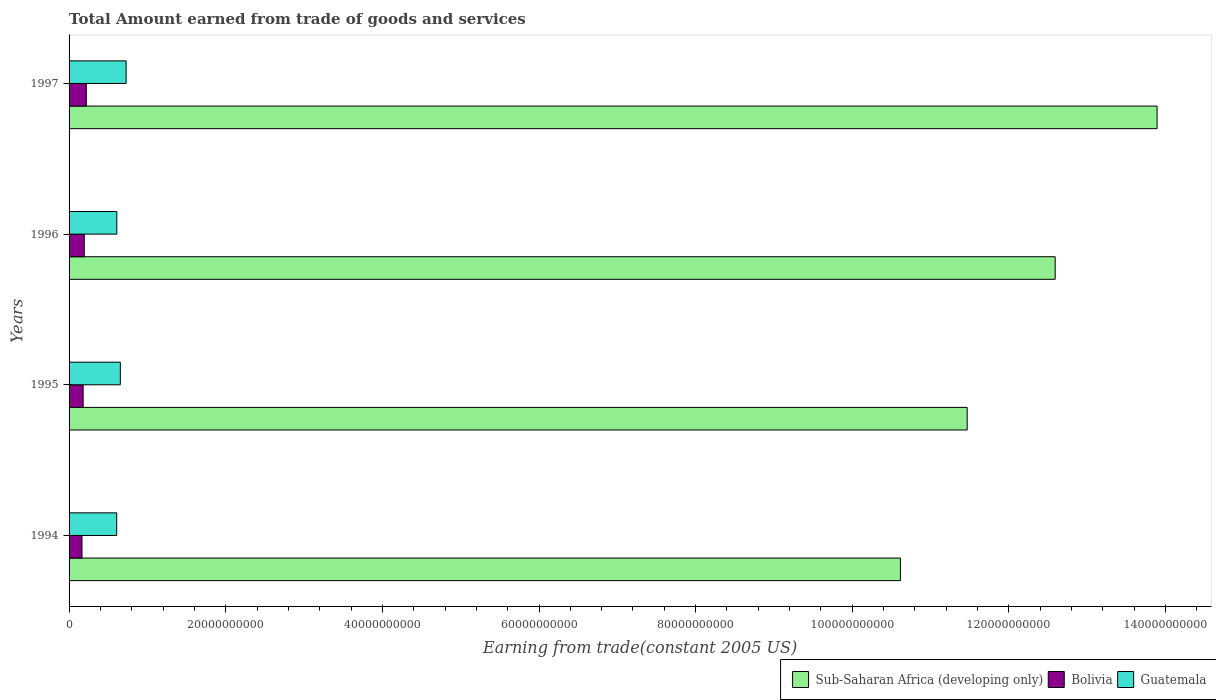How many different coloured bars are there?
Your answer should be very brief. 3. How many groups of bars are there?
Your answer should be compact. 4. How many bars are there on the 3rd tick from the bottom?
Provide a short and direct response. 3. What is the label of the 4th group of bars from the top?
Keep it short and to the point. 1994. What is the total amount earned by trading goods and services in Guatemala in 1996?
Your response must be concise. 6.09e+09. Across all years, what is the maximum total amount earned by trading goods and services in Sub-Saharan Africa (developing only)?
Offer a terse response. 1.39e+11. Across all years, what is the minimum total amount earned by trading goods and services in Guatemala?
Give a very brief answer. 6.08e+09. In which year was the total amount earned by trading goods and services in Sub-Saharan Africa (developing only) maximum?
Offer a terse response. 1997. In which year was the total amount earned by trading goods and services in Sub-Saharan Africa (developing only) minimum?
Your response must be concise. 1994. What is the total total amount earned by trading goods and services in Bolivia in the graph?
Give a very brief answer. 7.59e+09. What is the difference between the total amount earned by trading goods and services in Sub-Saharan Africa (developing only) in 1994 and that in 1997?
Provide a short and direct response. -3.28e+1. What is the difference between the total amount earned by trading goods and services in Bolivia in 1994 and the total amount earned by trading goods and services in Sub-Saharan Africa (developing only) in 1995?
Ensure brevity in your answer.  -1.13e+11. What is the average total amount earned by trading goods and services in Sub-Saharan Africa (developing only) per year?
Give a very brief answer. 1.21e+11. In the year 1995, what is the difference between the total amount earned by trading goods and services in Bolivia and total amount earned by trading goods and services in Sub-Saharan Africa (developing only)?
Ensure brevity in your answer.  -1.13e+11. What is the ratio of the total amount earned by trading goods and services in Sub-Saharan Africa (developing only) in 1994 to that in 1996?
Make the answer very short. 0.84. Is the total amount earned by trading goods and services in Sub-Saharan Africa (developing only) in 1995 less than that in 1997?
Provide a succinct answer. Yes. Is the difference between the total amount earned by trading goods and services in Bolivia in 1996 and 1997 greater than the difference between the total amount earned by trading goods and services in Sub-Saharan Africa (developing only) in 1996 and 1997?
Provide a succinct answer. Yes. What is the difference between the highest and the second highest total amount earned by trading goods and services in Bolivia?
Provide a short and direct response. 2.63e+08. What is the difference between the highest and the lowest total amount earned by trading goods and services in Bolivia?
Offer a terse response. 5.52e+08. In how many years, is the total amount earned by trading goods and services in Sub-Saharan Africa (developing only) greater than the average total amount earned by trading goods and services in Sub-Saharan Africa (developing only) taken over all years?
Keep it short and to the point. 2. Is the sum of the total amount earned by trading goods and services in Guatemala in 1995 and 1996 greater than the maximum total amount earned by trading goods and services in Bolivia across all years?
Your answer should be very brief. Yes. What does the 3rd bar from the bottom in 1995 represents?
Your answer should be compact. Guatemala. Is it the case that in every year, the sum of the total amount earned by trading goods and services in Bolivia and total amount earned by trading goods and services in Guatemala is greater than the total amount earned by trading goods and services in Sub-Saharan Africa (developing only)?
Make the answer very short. No. How many bars are there?
Ensure brevity in your answer.  12. Are all the bars in the graph horizontal?
Provide a succinct answer. Yes. Are the values on the major ticks of X-axis written in scientific E-notation?
Your answer should be very brief. No. Does the graph contain any zero values?
Provide a short and direct response. No. Where does the legend appear in the graph?
Your answer should be compact. Bottom right. How many legend labels are there?
Keep it short and to the point. 3. How are the legend labels stacked?
Your answer should be compact. Horizontal. What is the title of the graph?
Keep it short and to the point. Total Amount earned from trade of goods and services. Does "East Asia (developing only)" appear as one of the legend labels in the graph?
Your response must be concise. No. What is the label or title of the X-axis?
Your response must be concise. Earning from trade(constant 2005 US). What is the label or title of the Y-axis?
Keep it short and to the point. Years. What is the Earning from trade(constant 2005 US) in Sub-Saharan Africa (developing only) in 1994?
Provide a short and direct response. 1.06e+11. What is the Earning from trade(constant 2005 US) of Bolivia in 1994?
Provide a short and direct response. 1.65e+09. What is the Earning from trade(constant 2005 US) in Guatemala in 1994?
Your answer should be compact. 6.08e+09. What is the Earning from trade(constant 2005 US) of Sub-Saharan Africa (developing only) in 1995?
Make the answer very short. 1.15e+11. What is the Earning from trade(constant 2005 US) of Bolivia in 1995?
Give a very brief answer. 1.80e+09. What is the Earning from trade(constant 2005 US) of Guatemala in 1995?
Give a very brief answer. 6.54e+09. What is the Earning from trade(constant 2005 US) in Sub-Saharan Africa (developing only) in 1996?
Keep it short and to the point. 1.26e+11. What is the Earning from trade(constant 2005 US) in Bolivia in 1996?
Your answer should be very brief. 1.94e+09. What is the Earning from trade(constant 2005 US) in Guatemala in 1996?
Provide a succinct answer. 6.09e+09. What is the Earning from trade(constant 2005 US) in Sub-Saharan Africa (developing only) in 1997?
Provide a short and direct response. 1.39e+11. What is the Earning from trade(constant 2005 US) in Bolivia in 1997?
Ensure brevity in your answer.  2.20e+09. What is the Earning from trade(constant 2005 US) in Guatemala in 1997?
Your answer should be very brief. 7.28e+09. Across all years, what is the maximum Earning from trade(constant 2005 US) of Sub-Saharan Africa (developing only)?
Offer a terse response. 1.39e+11. Across all years, what is the maximum Earning from trade(constant 2005 US) in Bolivia?
Offer a very short reply. 2.20e+09. Across all years, what is the maximum Earning from trade(constant 2005 US) in Guatemala?
Provide a succinct answer. 7.28e+09. Across all years, what is the minimum Earning from trade(constant 2005 US) of Sub-Saharan Africa (developing only)?
Offer a terse response. 1.06e+11. Across all years, what is the minimum Earning from trade(constant 2005 US) of Bolivia?
Your answer should be very brief. 1.65e+09. Across all years, what is the minimum Earning from trade(constant 2005 US) in Guatemala?
Keep it short and to the point. 6.08e+09. What is the total Earning from trade(constant 2005 US) in Sub-Saharan Africa (developing only) in the graph?
Your answer should be compact. 4.86e+11. What is the total Earning from trade(constant 2005 US) in Bolivia in the graph?
Your response must be concise. 7.59e+09. What is the total Earning from trade(constant 2005 US) of Guatemala in the graph?
Give a very brief answer. 2.60e+1. What is the difference between the Earning from trade(constant 2005 US) in Sub-Saharan Africa (developing only) in 1994 and that in 1995?
Make the answer very short. -8.52e+09. What is the difference between the Earning from trade(constant 2005 US) of Bolivia in 1994 and that in 1995?
Keep it short and to the point. -1.47e+08. What is the difference between the Earning from trade(constant 2005 US) of Guatemala in 1994 and that in 1995?
Keep it short and to the point. -4.62e+08. What is the difference between the Earning from trade(constant 2005 US) of Sub-Saharan Africa (developing only) in 1994 and that in 1996?
Offer a terse response. -1.98e+1. What is the difference between the Earning from trade(constant 2005 US) of Bolivia in 1994 and that in 1996?
Provide a succinct answer. -2.90e+08. What is the difference between the Earning from trade(constant 2005 US) in Guatemala in 1994 and that in 1996?
Your answer should be compact. -1.27e+07. What is the difference between the Earning from trade(constant 2005 US) of Sub-Saharan Africa (developing only) in 1994 and that in 1997?
Keep it short and to the point. -3.28e+1. What is the difference between the Earning from trade(constant 2005 US) of Bolivia in 1994 and that in 1997?
Give a very brief answer. -5.52e+08. What is the difference between the Earning from trade(constant 2005 US) in Guatemala in 1994 and that in 1997?
Your answer should be compact. -1.20e+09. What is the difference between the Earning from trade(constant 2005 US) in Sub-Saharan Africa (developing only) in 1995 and that in 1996?
Ensure brevity in your answer.  -1.12e+1. What is the difference between the Earning from trade(constant 2005 US) of Bolivia in 1995 and that in 1996?
Ensure brevity in your answer.  -1.43e+08. What is the difference between the Earning from trade(constant 2005 US) of Guatemala in 1995 and that in 1996?
Provide a succinct answer. 4.49e+08. What is the difference between the Earning from trade(constant 2005 US) in Sub-Saharan Africa (developing only) in 1995 and that in 1997?
Provide a succinct answer. -2.42e+1. What is the difference between the Earning from trade(constant 2005 US) in Bolivia in 1995 and that in 1997?
Keep it short and to the point. -4.05e+08. What is the difference between the Earning from trade(constant 2005 US) in Guatemala in 1995 and that in 1997?
Give a very brief answer. -7.40e+08. What is the difference between the Earning from trade(constant 2005 US) in Sub-Saharan Africa (developing only) in 1996 and that in 1997?
Provide a succinct answer. -1.30e+1. What is the difference between the Earning from trade(constant 2005 US) in Bolivia in 1996 and that in 1997?
Give a very brief answer. -2.63e+08. What is the difference between the Earning from trade(constant 2005 US) in Guatemala in 1996 and that in 1997?
Give a very brief answer. -1.19e+09. What is the difference between the Earning from trade(constant 2005 US) in Sub-Saharan Africa (developing only) in 1994 and the Earning from trade(constant 2005 US) in Bolivia in 1995?
Your response must be concise. 1.04e+11. What is the difference between the Earning from trade(constant 2005 US) of Sub-Saharan Africa (developing only) in 1994 and the Earning from trade(constant 2005 US) of Guatemala in 1995?
Ensure brevity in your answer.  9.96e+1. What is the difference between the Earning from trade(constant 2005 US) of Bolivia in 1994 and the Earning from trade(constant 2005 US) of Guatemala in 1995?
Ensure brevity in your answer.  -4.89e+09. What is the difference between the Earning from trade(constant 2005 US) of Sub-Saharan Africa (developing only) in 1994 and the Earning from trade(constant 2005 US) of Bolivia in 1996?
Your response must be concise. 1.04e+11. What is the difference between the Earning from trade(constant 2005 US) of Sub-Saharan Africa (developing only) in 1994 and the Earning from trade(constant 2005 US) of Guatemala in 1996?
Ensure brevity in your answer.  1.00e+11. What is the difference between the Earning from trade(constant 2005 US) of Bolivia in 1994 and the Earning from trade(constant 2005 US) of Guatemala in 1996?
Offer a very short reply. -4.44e+09. What is the difference between the Earning from trade(constant 2005 US) in Sub-Saharan Africa (developing only) in 1994 and the Earning from trade(constant 2005 US) in Bolivia in 1997?
Ensure brevity in your answer.  1.04e+11. What is the difference between the Earning from trade(constant 2005 US) of Sub-Saharan Africa (developing only) in 1994 and the Earning from trade(constant 2005 US) of Guatemala in 1997?
Make the answer very short. 9.89e+1. What is the difference between the Earning from trade(constant 2005 US) of Bolivia in 1994 and the Earning from trade(constant 2005 US) of Guatemala in 1997?
Your response must be concise. -5.63e+09. What is the difference between the Earning from trade(constant 2005 US) in Sub-Saharan Africa (developing only) in 1995 and the Earning from trade(constant 2005 US) in Bolivia in 1996?
Your answer should be compact. 1.13e+11. What is the difference between the Earning from trade(constant 2005 US) of Sub-Saharan Africa (developing only) in 1995 and the Earning from trade(constant 2005 US) of Guatemala in 1996?
Offer a terse response. 1.09e+11. What is the difference between the Earning from trade(constant 2005 US) in Bolivia in 1995 and the Earning from trade(constant 2005 US) in Guatemala in 1996?
Provide a short and direct response. -4.30e+09. What is the difference between the Earning from trade(constant 2005 US) in Sub-Saharan Africa (developing only) in 1995 and the Earning from trade(constant 2005 US) in Bolivia in 1997?
Your answer should be very brief. 1.12e+11. What is the difference between the Earning from trade(constant 2005 US) in Sub-Saharan Africa (developing only) in 1995 and the Earning from trade(constant 2005 US) in Guatemala in 1997?
Ensure brevity in your answer.  1.07e+11. What is the difference between the Earning from trade(constant 2005 US) of Bolivia in 1995 and the Earning from trade(constant 2005 US) of Guatemala in 1997?
Offer a terse response. -5.49e+09. What is the difference between the Earning from trade(constant 2005 US) of Sub-Saharan Africa (developing only) in 1996 and the Earning from trade(constant 2005 US) of Bolivia in 1997?
Provide a short and direct response. 1.24e+11. What is the difference between the Earning from trade(constant 2005 US) in Sub-Saharan Africa (developing only) in 1996 and the Earning from trade(constant 2005 US) in Guatemala in 1997?
Your answer should be very brief. 1.19e+11. What is the difference between the Earning from trade(constant 2005 US) in Bolivia in 1996 and the Earning from trade(constant 2005 US) in Guatemala in 1997?
Ensure brevity in your answer.  -5.34e+09. What is the average Earning from trade(constant 2005 US) in Sub-Saharan Africa (developing only) per year?
Your response must be concise. 1.21e+11. What is the average Earning from trade(constant 2005 US) of Bolivia per year?
Offer a very short reply. 1.90e+09. What is the average Earning from trade(constant 2005 US) of Guatemala per year?
Make the answer very short. 6.50e+09. In the year 1994, what is the difference between the Earning from trade(constant 2005 US) in Sub-Saharan Africa (developing only) and Earning from trade(constant 2005 US) in Bolivia?
Offer a terse response. 1.04e+11. In the year 1994, what is the difference between the Earning from trade(constant 2005 US) in Sub-Saharan Africa (developing only) and Earning from trade(constant 2005 US) in Guatemala?
Offer a terse response. 1.00e+11. In the year 1994, what is the difference between the Earning from trade(constant 2005 US) in Bolivia and Earning from trade(constant 2005 US) in Guatemala?
Make the answer very short. -4.43e+09. In the year 1995, what is the difference between the Earning from trade(constant 2005 US) in Sub-Saharan Africa (developing only) and Earning from trade(constant 2005 US) in Bolivia?
Your response must be concise. 1.13e+11. In the year 1995, what is the difference between the Earning from trade(constant 2005 US) in Sub-Saharan Africa (developing only) and Earning from trade(constant 2005 US) in Guatemala?
Give a very brief answer. 1.08e+11. In the year 1995, what is the difference between the Earning from trade(constant 2005 US) of Bolivia and Earning from trade(constant 2005 US) of Guatemala?
Your answer should be compact. -4.75e+09. In the year 1996, what is the difference between the Earning from trade(constant 2005 US) of Sub-Saharan Africa (developing only) and Earning from trade(constant 2005 US) of Bolivia?
Your answer should be very brief. 1.24e+11. In the year 1996, what is the difference between the Earning from trade(constant 2005 US) of Sub-Saharan Africa (developing only) and Earning from trade(constant 2005 US) of Guatemala?
Ensure brevity in your answer.  1.20e+11. In the year 1996, what is the difference between the Earning from trade(constant 2005 US) in Bolivia and Earning from trade(constant 2005 US) in Guatemala?
Keep it short and to the point. -4.16e+09. In the year 1997, what is the difference between the Earning from trade(constant 2005 US) in Sub-Saharan Africa (developing only) and Earning from trade(constant 2005 US) in Bolivia?
Your answer should be very brief. 1.37e+11. In the year 1997, what is the difference between the Earning from trade(constant 2005 US) of Sub-Saharan Africa (developing only) and Earning from trade(constant 2005 US) of Guatemala?
Offer a terse response. 1.32e+11. In the year 1997, what is the difference between the Earning from trade(constant 2005 US) of Bolivia and Earning from trade(constant 2005 US) of Guatemala?
Offer a terse response. -5.08e+09. What is the ratio of the Earning from trade(constant 2005 US) in Sub-Saharan Africa (developing only) in 1994 to that in 1995?
Give a very brief answer. 0.93. What is the ratio of the Earning from trade(constant 2005 US) of Bolivia in 1994 to that in 1995?
Your answer should be compact. 0.92. What is the ratio of the Earning from trade(constant 2005 US) in Guatemala in 1994 to that in 1995?
Ensure brevity in your answer.  0.93. What is the ratio of the Earning from trade(constant 2005 US) of Sub-Saharan Africa (developing only) in 1994 to that in 1996?
Your answer should be very brief. 0.84. What is the ratio of the Earning from trade(constant 2005 US) in Bolivia in 1994 to that in 1996?
Your answer should be compact. 0.85. What is the ratio of the Earning from trade(constant 2005 US) in Sub-Saharan Africa (developing only) in 1994 to that in 1997?
Offer a terse response. 0.76. What is the ratio of the Earning from trade(constant 2005 US) in Bolivia in 1994 to that in 1997?
Your answer should be very brief. 0.75. What is the ratio of the Earning from trade(constant 2005 US) in Guatemala in 1994 to that in 1997?
Provide a short and direct response. 0.84. What is the ratio of the Earning from trade(constant 2005 US) of Sub-Saharan Africa (developing only) in 1995 to that in 1996?
Your answer should be very brief. 0.91. What is the ratio of the Earning from trade(constant 2005 US) of Bolivia in 1995 to that in 1996?
Ensure brevity in your answer.  0.93. What is the ratio of the Earning from trade(constant 2005 US) of Guatemala in 1995 to that in 1996?
Offer a very short reply. 1.07. What is the ratio of the Earning from trade(constant 2005 US) of Sub-Saharan Africa (developing only) in 1995 to that in 1997?
Make the answer very short. 0.83. What is the ratio of the Earning from trade(constant 2005 US) in Bolivia in 1995 to that in 1997?
Ensure brevity in your answer.  0.82. What is the ratio of the Earning from trade(constant 2005 US) in Guatemala in 1995 to that in 1997?
Keep it short and to the point. 0.9. What is the ratio of the Earning from trade(constant 2005 US) of Sub-Saharan Africa (developing only) in 1996 to that in 1997?
Keep it short and to the point. 0.91. What is the ratio of the Earning from trade(constant 2005 US) of Bolivia in 1996 to that in 1997?
Make the answer very short. 0.88. What is the ratio of the Earning from trade(constant 2005 US) of Guatemala in 1996 to that in 1997?
Offer a very short reply. 0.84. What is the difference between the highest and the second highest Earning from trade(constant 2005 US) of Sub-Saharan Africa (developing only)?
Give a very brief answer. 1.30e+1. What is the difference between the highest and the second highest Earning from trade(constant 2005 US) of Bolivia?
Offer a terse response. 2.63e+08. What is the difference between the highest and the second highest Earning from trade(constant 2005 US) in Guatemala?
Give a very brief answer. 7.40e+08. What is the difference between the highest and the lowest Earning from trade(constant 2005 US) in Sub-Saharan Africa (developing only)?
Your response must be concise. 3.28e+1. What is the difference between the highest and the lowest Earning from trade(constant 2005 US) in Bolivia?
Your answer should be compact. 5.52e+08. What is the difference between the highest and the lowest Earning from trade(constant 2005 US) in Guatemala?
Offer a very short reply. 1.20e+09. 